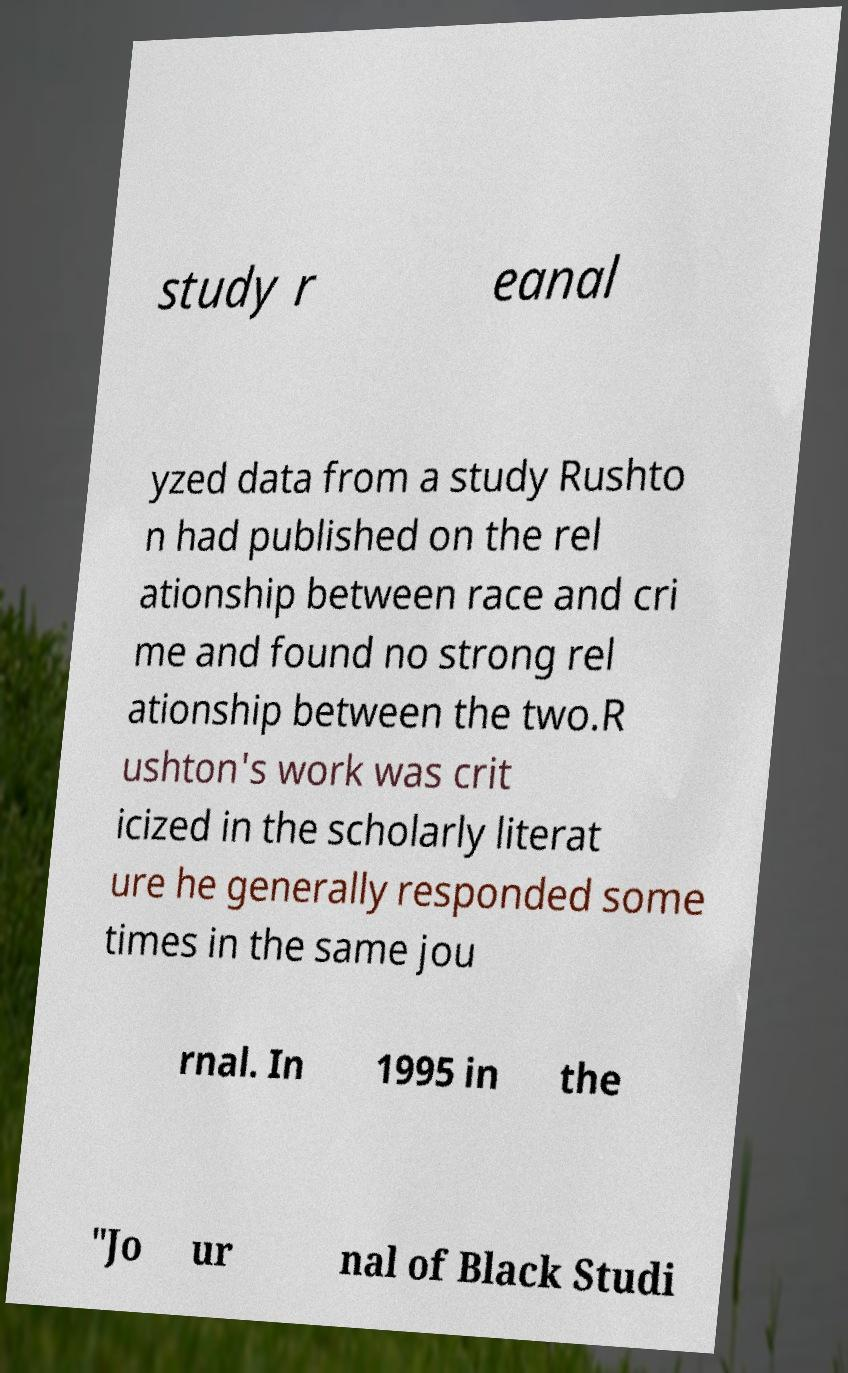I need the written content from this picture converted into text. Can you do that? study r eanal yzed data from a study Rushto n had published on the rel ationship between race and cri me and found no strong rel ationship between the two.R ushton's work was crit icized in the scholarly literat ure he generally responded some times in the same jou rnal. In 1995 in the "Jo ur nal of Black Studi 